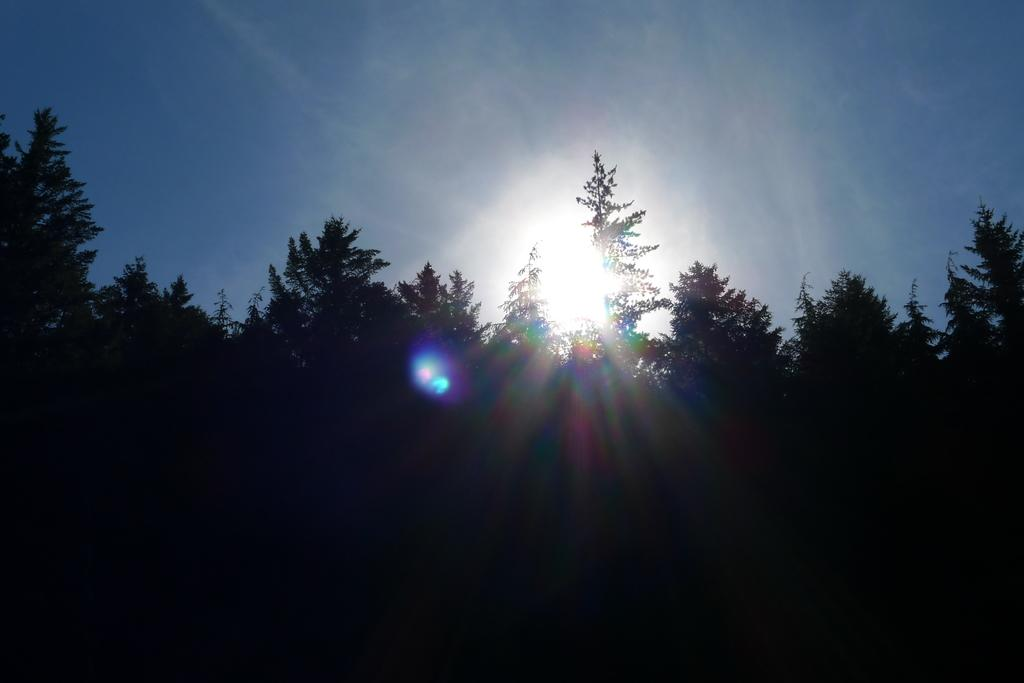What is located in the center of the image? There are trees in the center of the image. What is visible in the background of the image? The sky is visible in the background of the image. Can you see any fairies flying around the trees in the image? There are no fairies present in the image. What type of crayon is being used to draw the trees in the image? The image is a photograph, not a drawing, so there is no crayon present. 